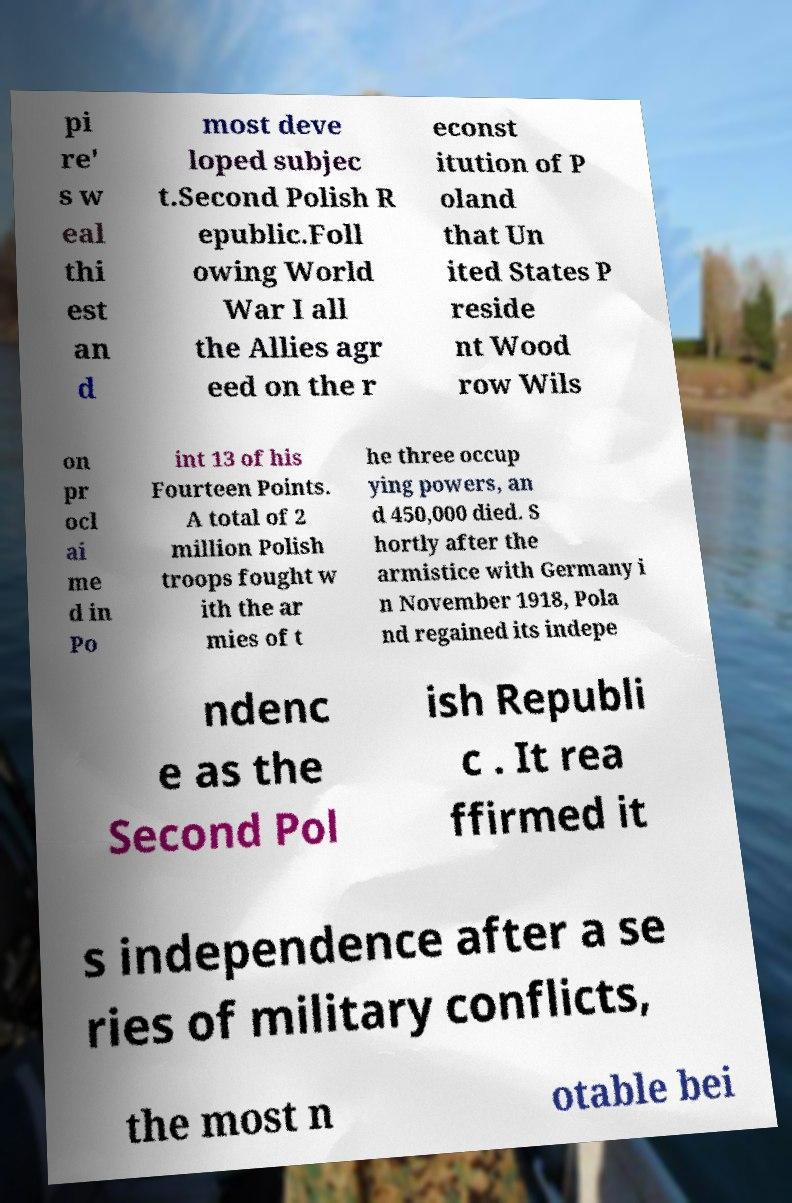Can you read and provide the text displayed in the image?This photo seems to have some interesting text. Can you extract and type it out for me? pi re' s w eal thi est an d most deve loped subjec t.Second Polish R epublic.Foll owing World War I all the Allies agr eed on the r econst itution of P oland that Un ited States P reside nt Wood row Wils on pr ocl ai me d in Po int 13 of his Fourteen Points. A total of 2 million Polish troops fought w ith the ar mies of t he three occup ying powers, an d 450,000 died. S hortly after the armistice with Germany i n November 1918, Pola nd regained its indepe ndenc e as the Second Pol ish Republi c . It rea ffirmed it s independence after a se ries of military conflicts, the most n otable bei 